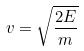<formula> <loc_0><loc_0><loc_500><loc_500>v = \sqrt { \frac { 2 E } { m } }</formula> 